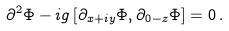<formula> <loc_0><loc_0><loc_500><loc_500>\partial ^ { 2 } \Phi - i g \, [ \partial _ { x + i y } \Phi , \partial _ { 0 - z } \Phi ] = 0 \, .</formula> 